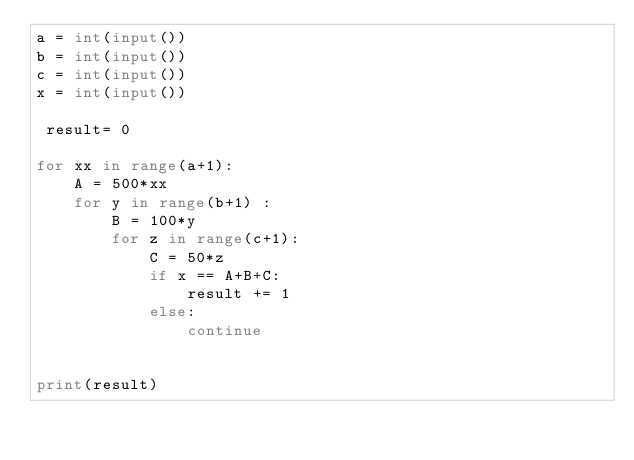<code> <loc_0><loc_0><loc_500><loc_500><_Python_>a = int(input())
b = int(input())
c = int(input())
x = int(input())
 
 result= 0
 
for xx in range(a+1):
    A = 500*xx
    for y in range(b+1) :
        B = 100*y
        for z in range(c+1):
            C = 50*z
            if x == A+B+C:
                result += 1
            else:
                continue
 
 
print(result)</code> 